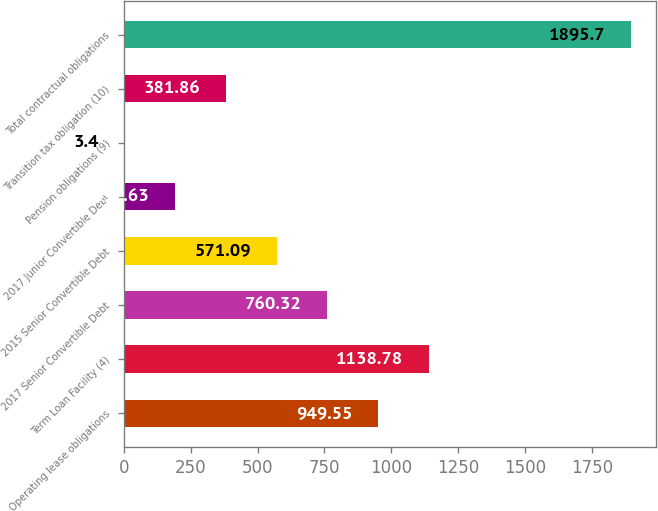Convert chart. <chart><loc_0><loc_0><loc_500><loc_500><bar_chart><fcel>Operating lease obligations<fcel>Term Loan Facility (4)<fcel>2017 Senior Convertible Debt<fcel>2015 Senior Convertible Debt<fcel>2017 Junior Convertible Debt<fcel>Pension obligations (9)<fcel>Transition tax obligation (10)<fcel>Total contractual obligations<nl><fcel>949.55<fcel>1138.78<fcel>760.32<fcel>571.09<fcel>192.63<fcel>3.4<fcel>381.86<fcel>1895.7<nl></chart> 